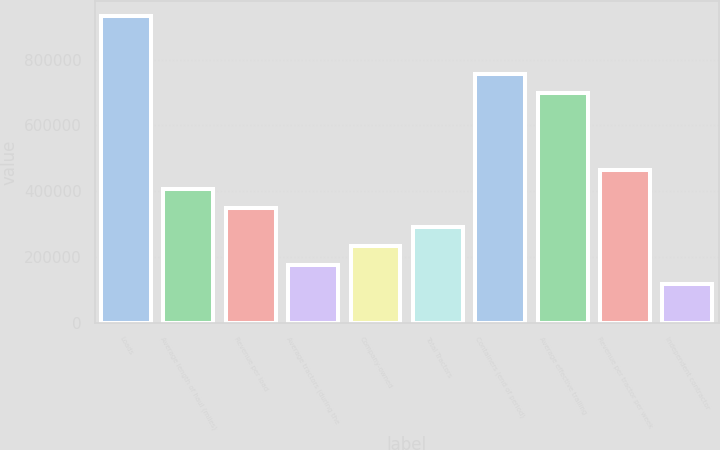Convert chart. <chart><loc_0><loc_0><loc_500><loc_500><bar_chart><fcel>Loads<fcel>Average length of haul (miles)<fcel>Revenue per load<fcel>Average tractors (during the<fcel>Company-owned<fcel>Total Tractors<fcel>Containers (end of period)<fcel>Average effective trailing<fcel>Revenue per tractor per week<fcel>Independent contractor<nl><fcel>930925<fcel>407311<fcel>349132<fcel>174594<fcel>232773<fcel>290953<fcel>756387<fcel>698208<fcel>465490<fcel>116415<nl></chart> 